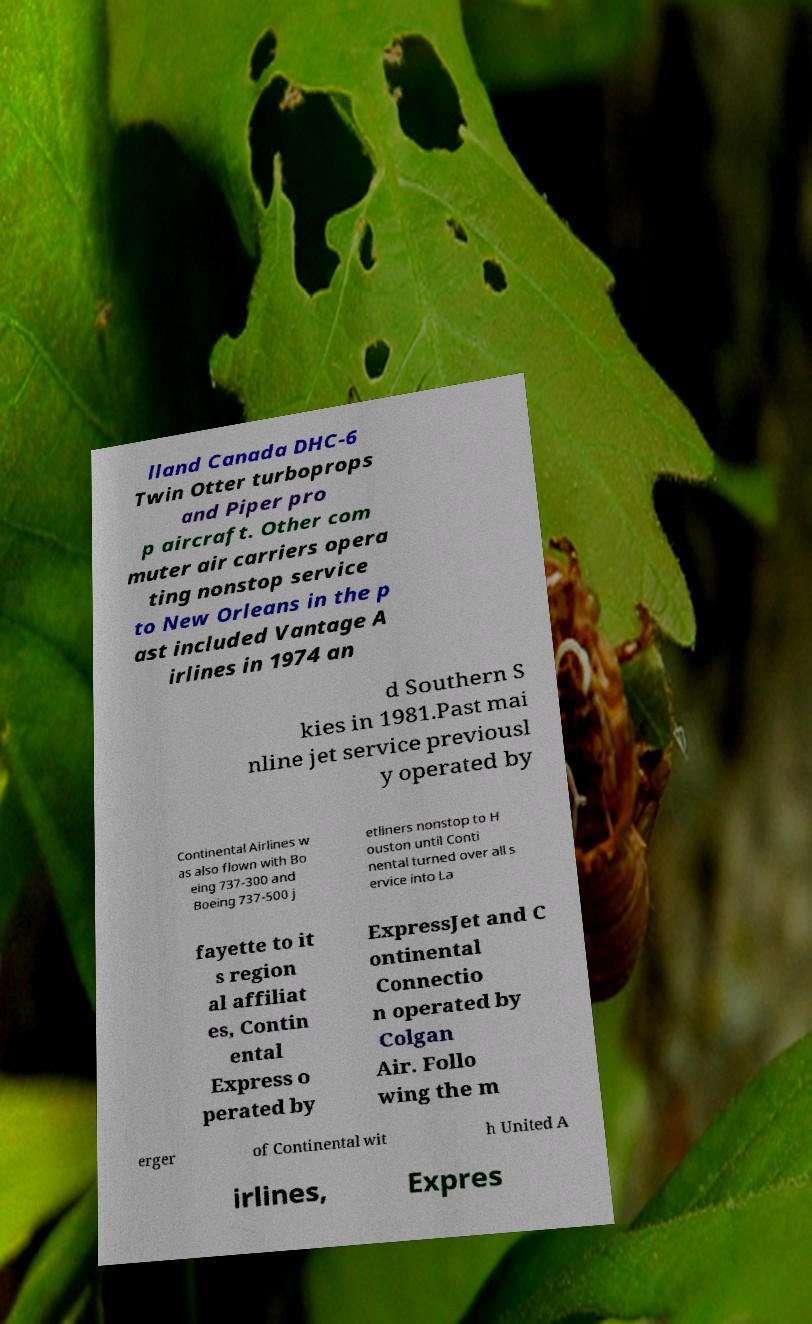Please read and relay the text visible in this image. What does it say? lland Canada DHC-6 Twin Otter turboprops and Piper pro p aircraft. Other com muter air carriers opera ting nonstop service to New Orleans in the p ast included Vantage A irlines in 1974 an d Southern S kies in 1981.Past mai nline jet service previousl y operated by Continental Airlines w as also flown with Bo eing 737-300 and Boeing 737-500 j etliners nonstop to H ouston until Conti nental turned over all s ervice into La fayette to it s region al affiliat es, Contin ental Express o perated by ExpressJet and C ontinental Connectio n operated by Colgan Air. Follo wing the m erger of Continental wit h United A irlines, Expres 